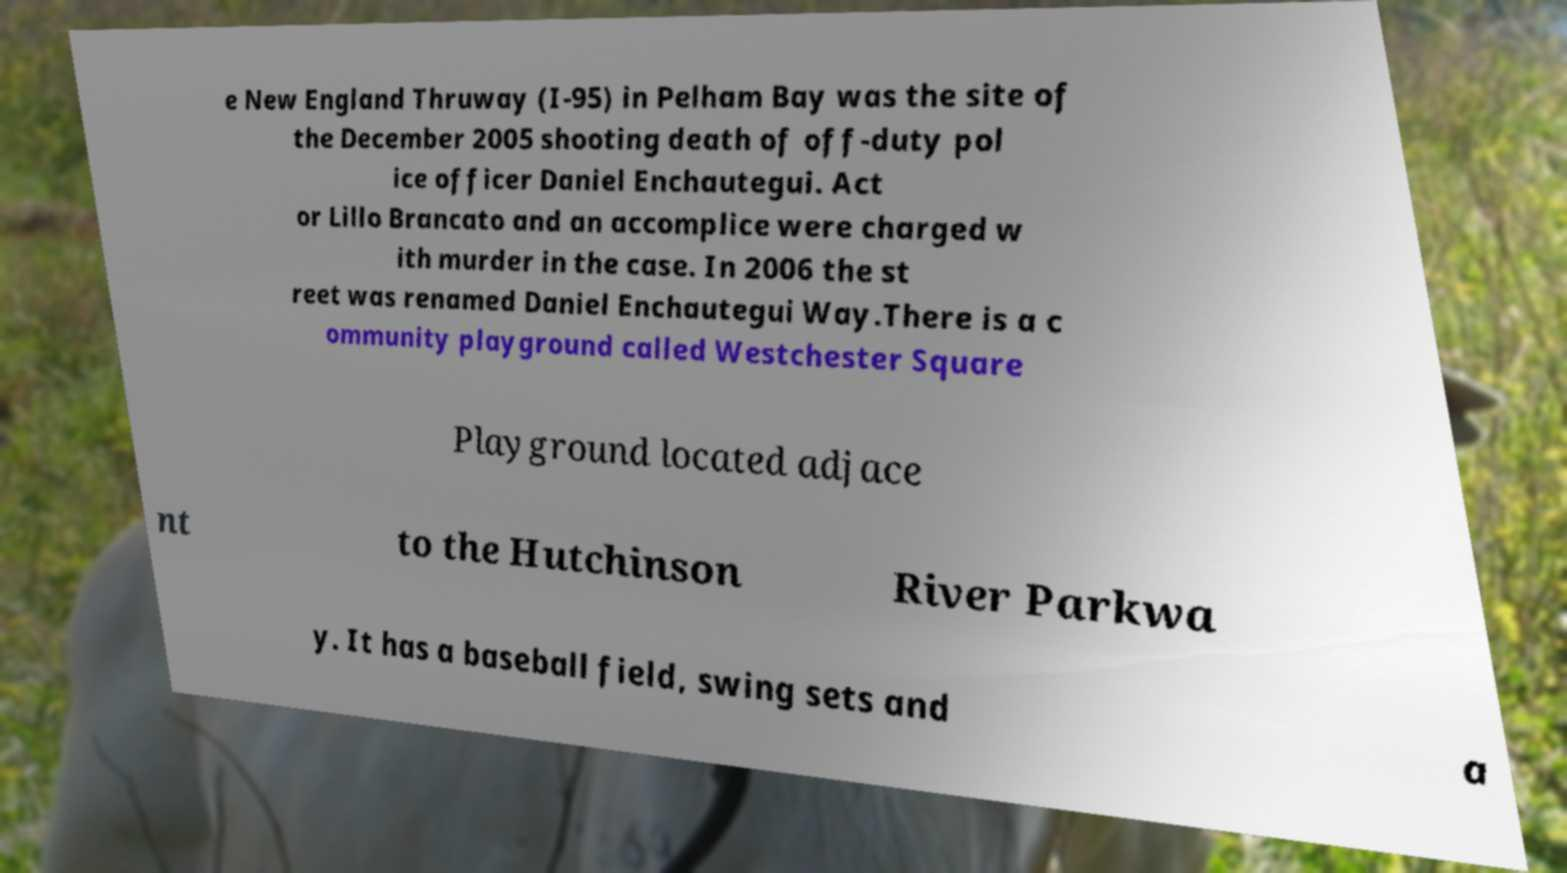Could you extract and type out the text from this image? e New England Thruway (I-95) in Pelham Bay was the site of the December 2005 shooting death of off-duty pol ice officer Daniel Enchautegui. Act or Lillo Brancato and an accomplice were charged w ith murder in the case. In 2006 the st reet was renamed Daniel Enchautegui Way.There is a c ommunity playground called Westchester Square Playground located adjace nt to the Hutchinson River Parkwa y. It has a baseball field, swing sets and a 